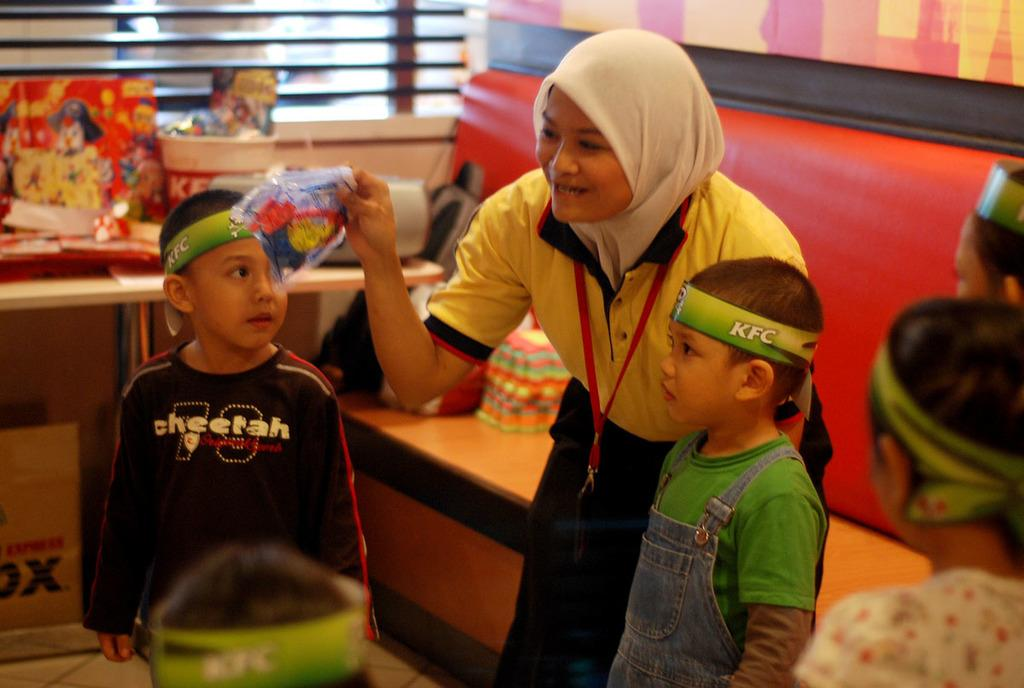Who is present in the image? There are children and a person in the image. What is the setting of the image? There is a table and a window in the image, suggesting an indoor setting. What object can be seen near the children? There is a cardboard box in the image. How many feet can be seen in the image? There is no mention of feet in the image, so it is impossible to determine how many feet are visible. 